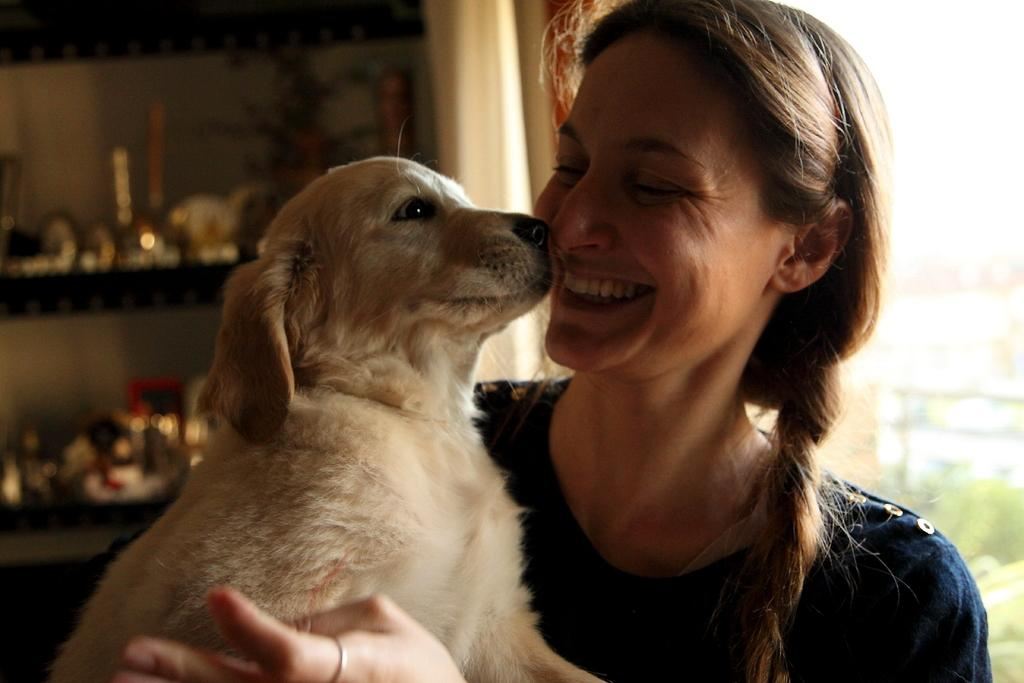What type of person is in the image? There is a lady person in the image. What animal is present in the image? There is a puppy in the image. What type of wax can be seen on the lady person's finger in the image? There is no wax or mention of wax on the lady person's finger in the image. What type of coat is the puppy wearing in the image? The image does not show the puppy wearing a coat; it is not present. 